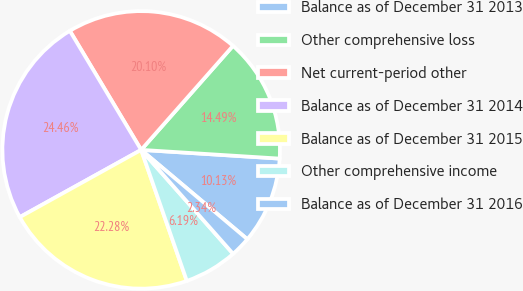Convert chart to OTSL. <chart><loc_0><loc_0><loc_500><loc_500><pie_chart><fcel>Balance as of December 31 2013<fcel>Other comprehensive loss<fcel>Net current-period other<fcel>Balance as of December 31 2014<fcel>Balance as of December 31 2015<fcel>Other comprehensive income<fcel>Balance as of December 31 2016<nl><fcel>10.13%<fcel>14.49%<fcel>20.1%<fcel>24.46%<fcel>22.28%<fcel>6.19%<fcel>2.34%<nl></chart> 